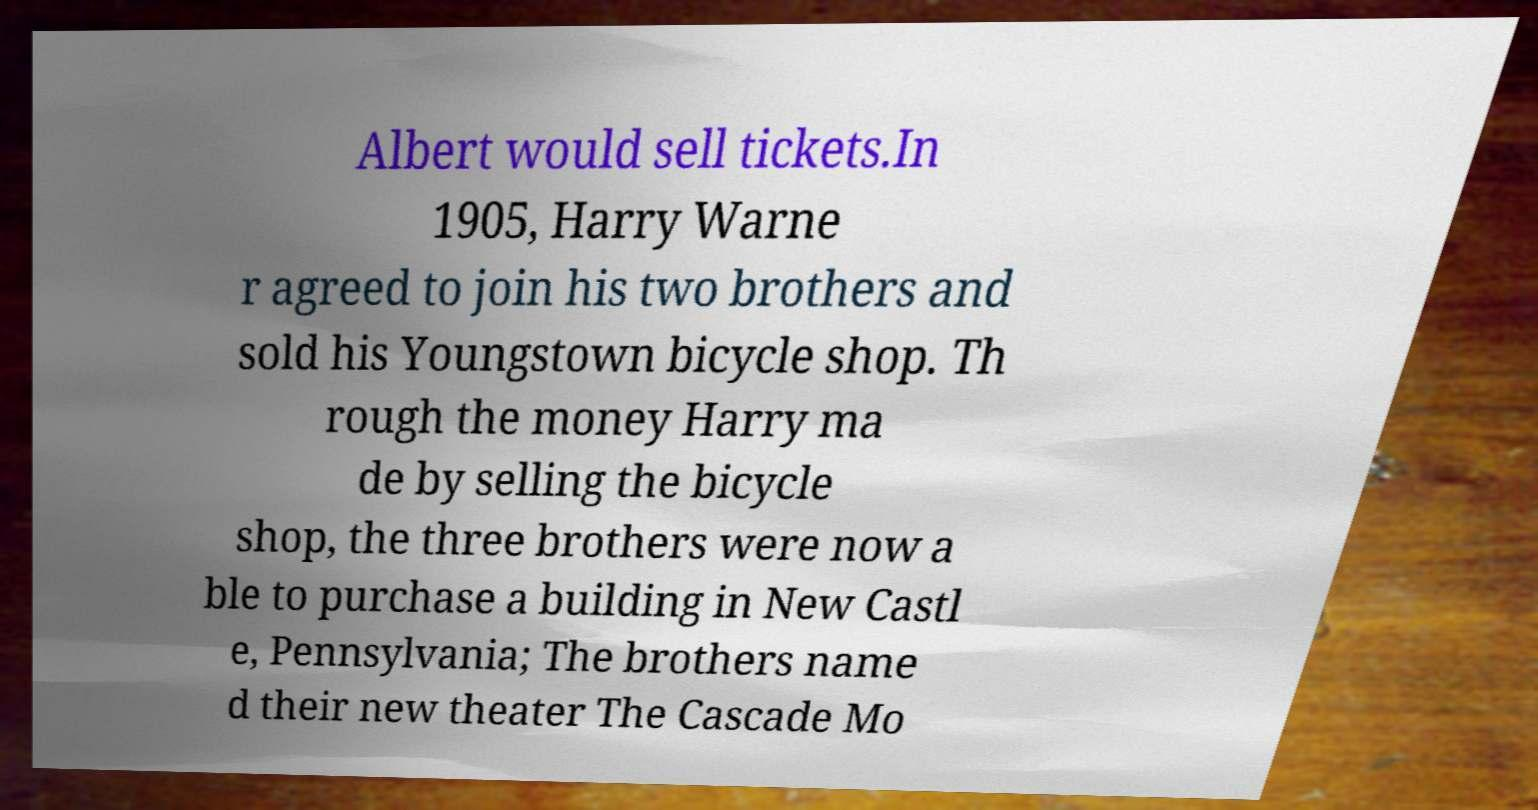Please identify and transcribe the text found in this image. Albert would sell tickets.In 1905, Harry Warne r agreed to join his two brothers and sold his Youngstown bicycle shop. Th rough the money Harry ma de by selling the bicycle shop, the three brothers were now a ble to purchase a building in New Castl e, Pennsylvania; The brothers name d their new theater The Cascade Mo 